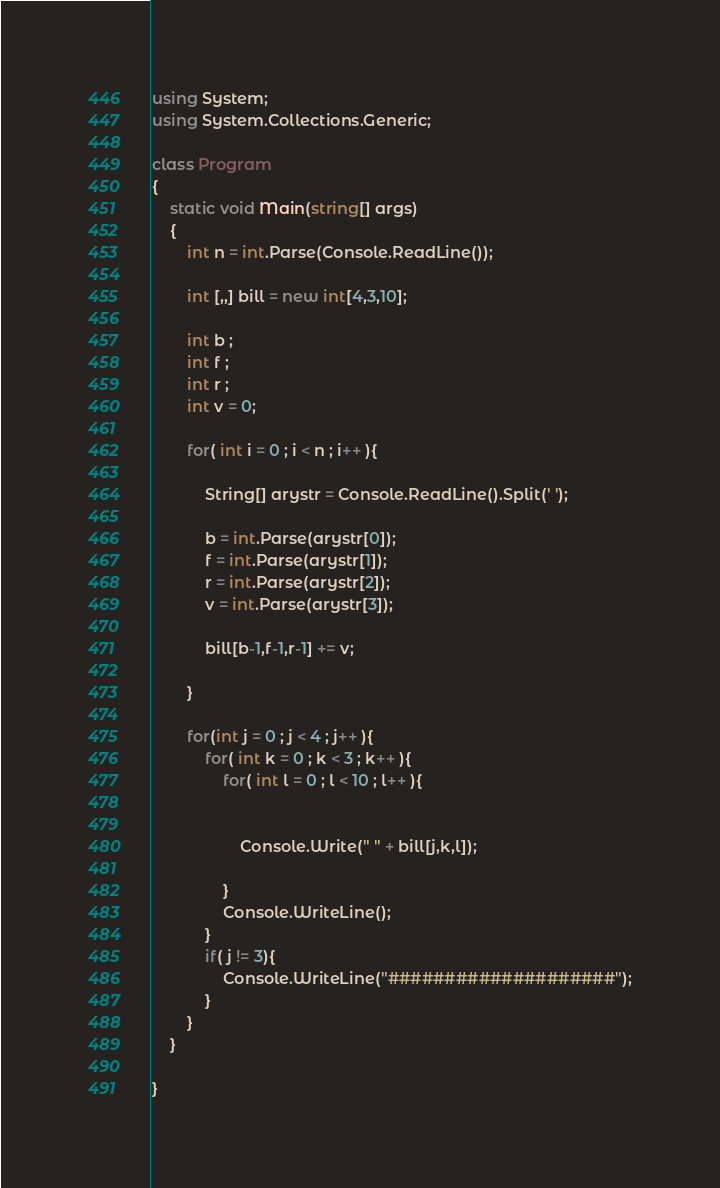<code> <loc_0><loc_0><loc_500><loc_500><_C#_>using System;
using System.Collections.Generic;

class Program
{
    static void Main(string[] args)
    {
        int n = int.Parse(Console.ReadLine());
         
        int [,,] bill = new int[4,3,10];
         
        int b ;
        int f ;
        int r ;
        int v = 0;
         
        for( int i = 0 ; i < n ; i++ ){

            String[] arystr = Console.ReadLine().Split(' ');
             
            b = int.Parse(arystr[0]);
            f = int.Parse(arystr[1]);
            r = int.Parse(arystr[2]);
            v = int.Parse(arystr[3]);
             
            bill[b-1,f-1,r-1] += v;
            
        }
             
        for(int j = 0 ; j < 4 ; j++ ){
            for( int k = 0 ; k < 3 ; k++ ){
                for( int l = 0 ; l < 10 ; l++ ){
                     
                     
                    Console.Write(" " + bill[j,k,l]);
                     
                }
                Console.WriteLine();
            }
            if( j != 3){
                Console.WriteLine("####################");
            }
        } 
    }
    
}</code> 